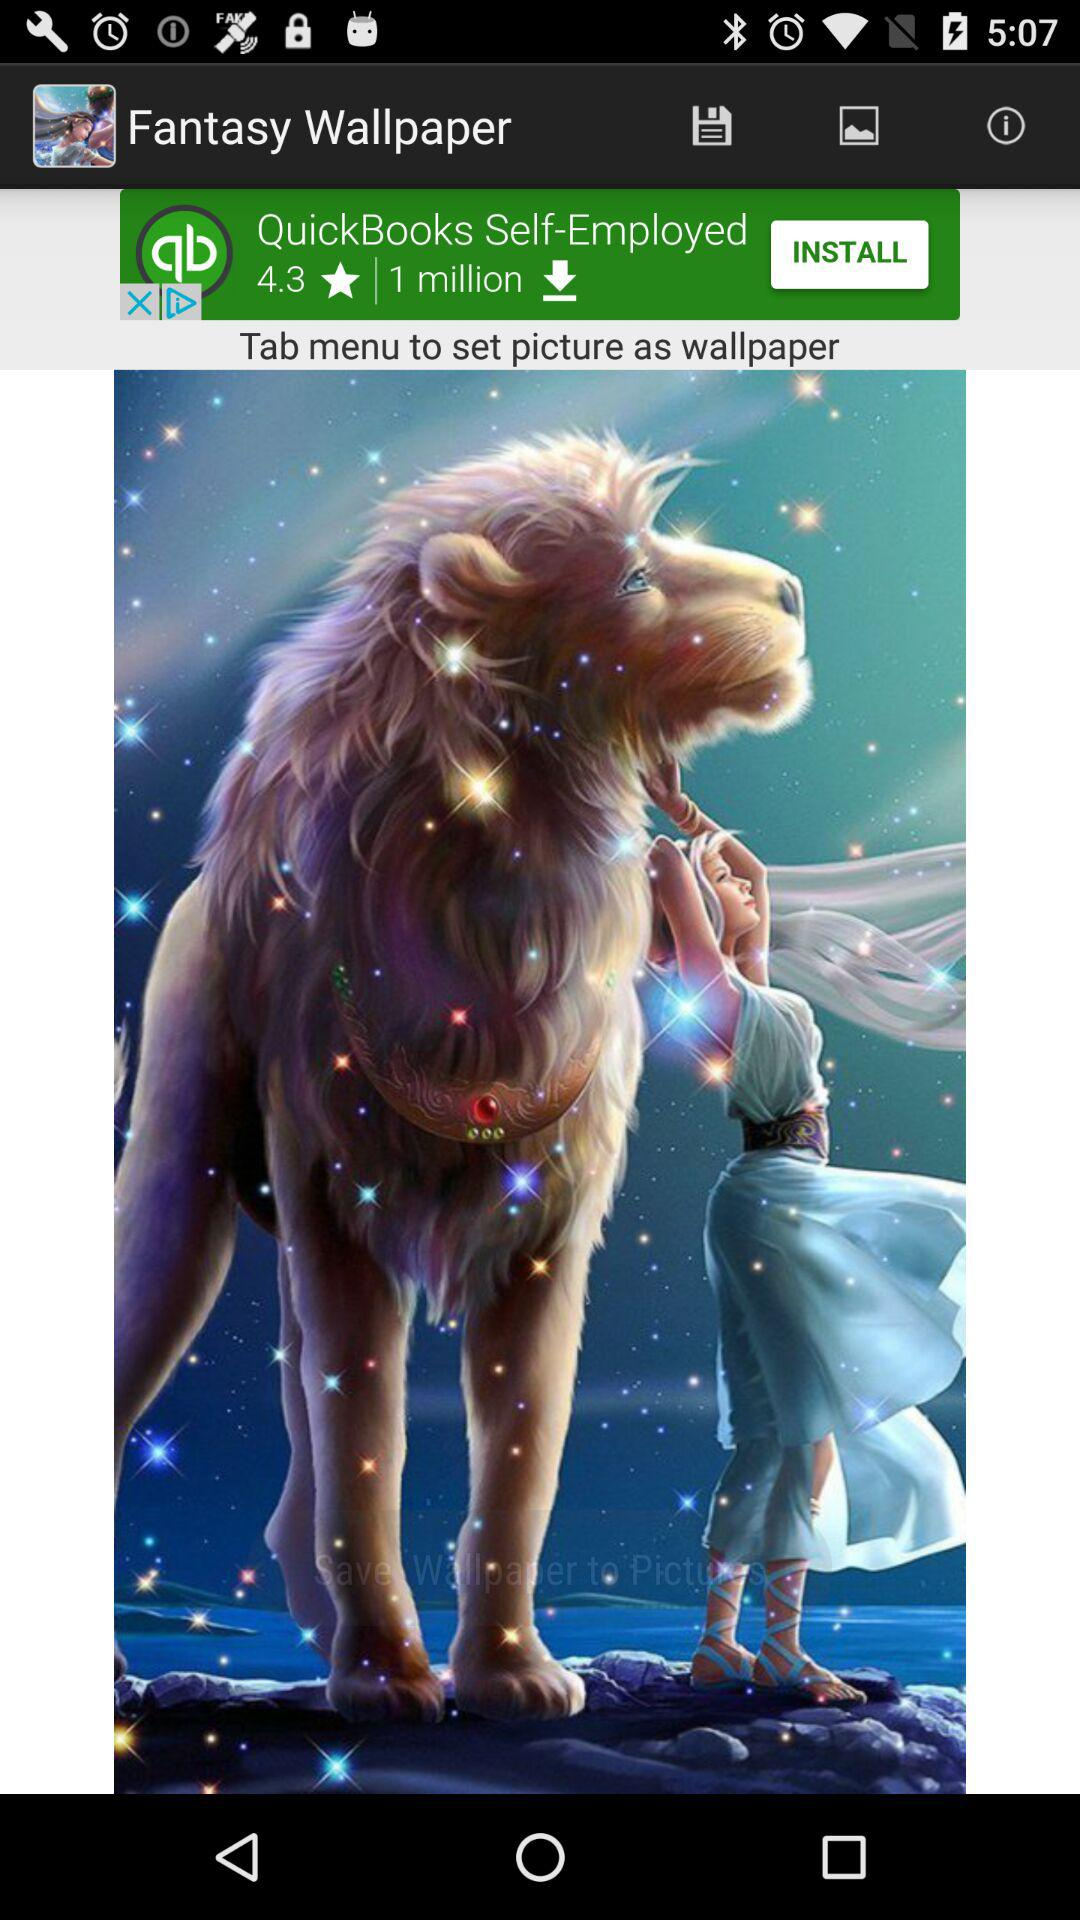What is the name of the application? The name of the application is "Fantasy Wallpaper". 